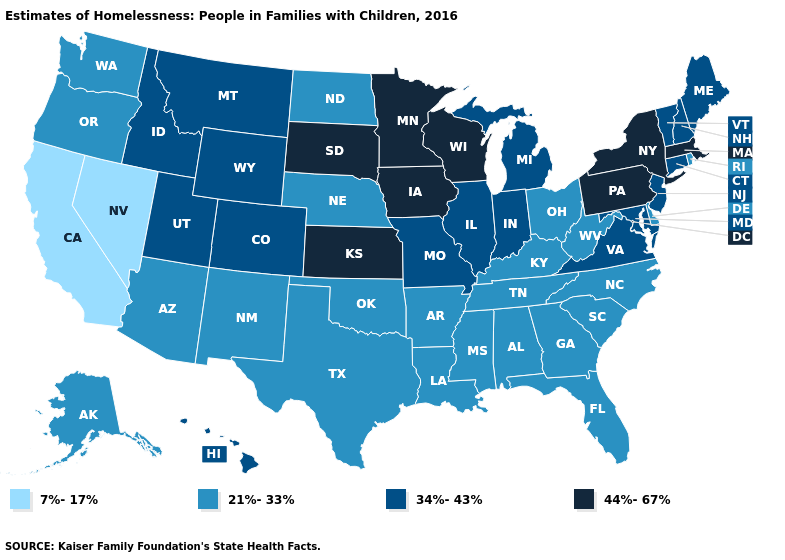Name the states that have a value in the range 7%-17%?
Short answer required. California, Nevada. What is the lowest value in the South?
Answer briefly. 21%-33%. What is the value of Indiana?
Quick response, please. 34%-43%. What is the highest value in states that border Georgia?
Quick response, please. 21%-33%. Does Pennsylvania have a higher value than Minnesota?
Keep it brief. No. What is the value of New Hampshire?
Quick response, please. 34%-43%. Does Wisconsin have the highest value in the USA?
Quick response, please. Yes. What is the value of Michigan?
Be succinct. 34%-43%. What is the value of New York?
Keep it brief. 44%-67%. Does Wisconsin have the same value as Kansas?
Quick response, please. Yes. Does Maryland have the highest value in the South?
Be succinct. Yes. Which states have the lowest value in the USA?
Give a very brief answer. California, Nevada. Among the states that border New Hampshire , does Massachusetts have the lowest value?
Short answer required. No. What is the lowest value in the USA?
Answer briefly. 7%-17%. 